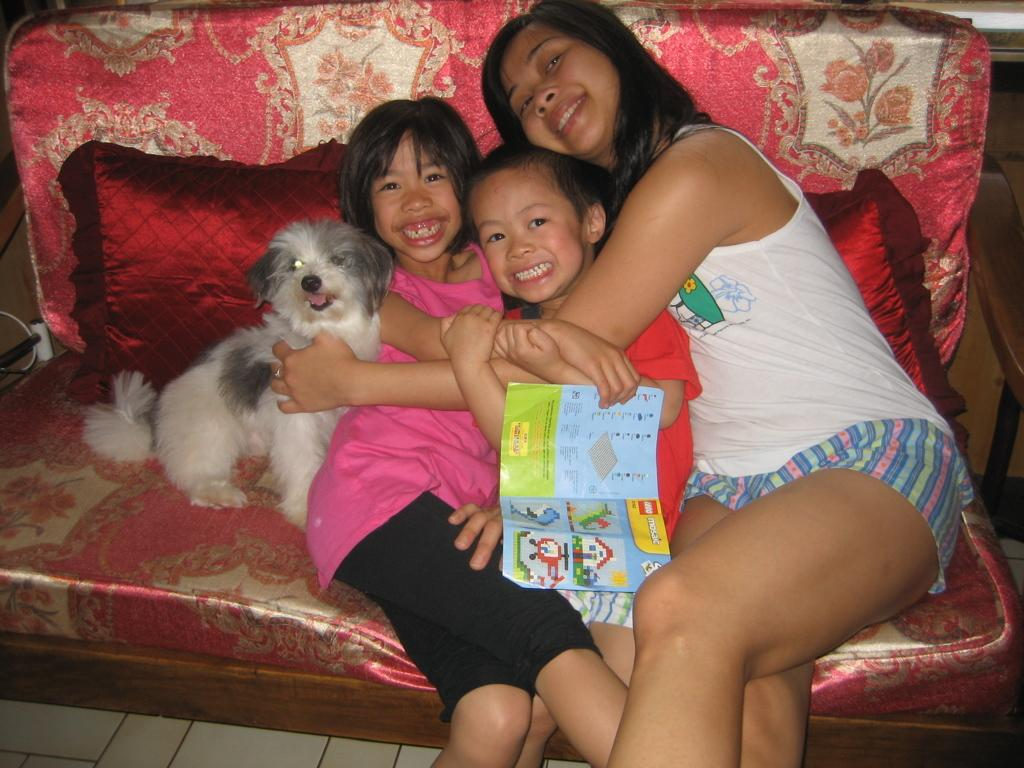How many individuals are present in the image? There are three people in the image. What other living creature is present in the image? There is a dog in the image. Where are the people and the dog located? They are sitting on a sofa. Can you describe the facial expression of the girl on the left side? The girl on the left side is smiling. What is the woman on the right side doing? The woman on the right side is holding two people and the dog. What is the baby's role in the committee meeting in the image? There is no baby or committee meeting present in the image. How fast is the dog running in the image? The dog is not running in the image; it is sitting on the sofa with the people. 